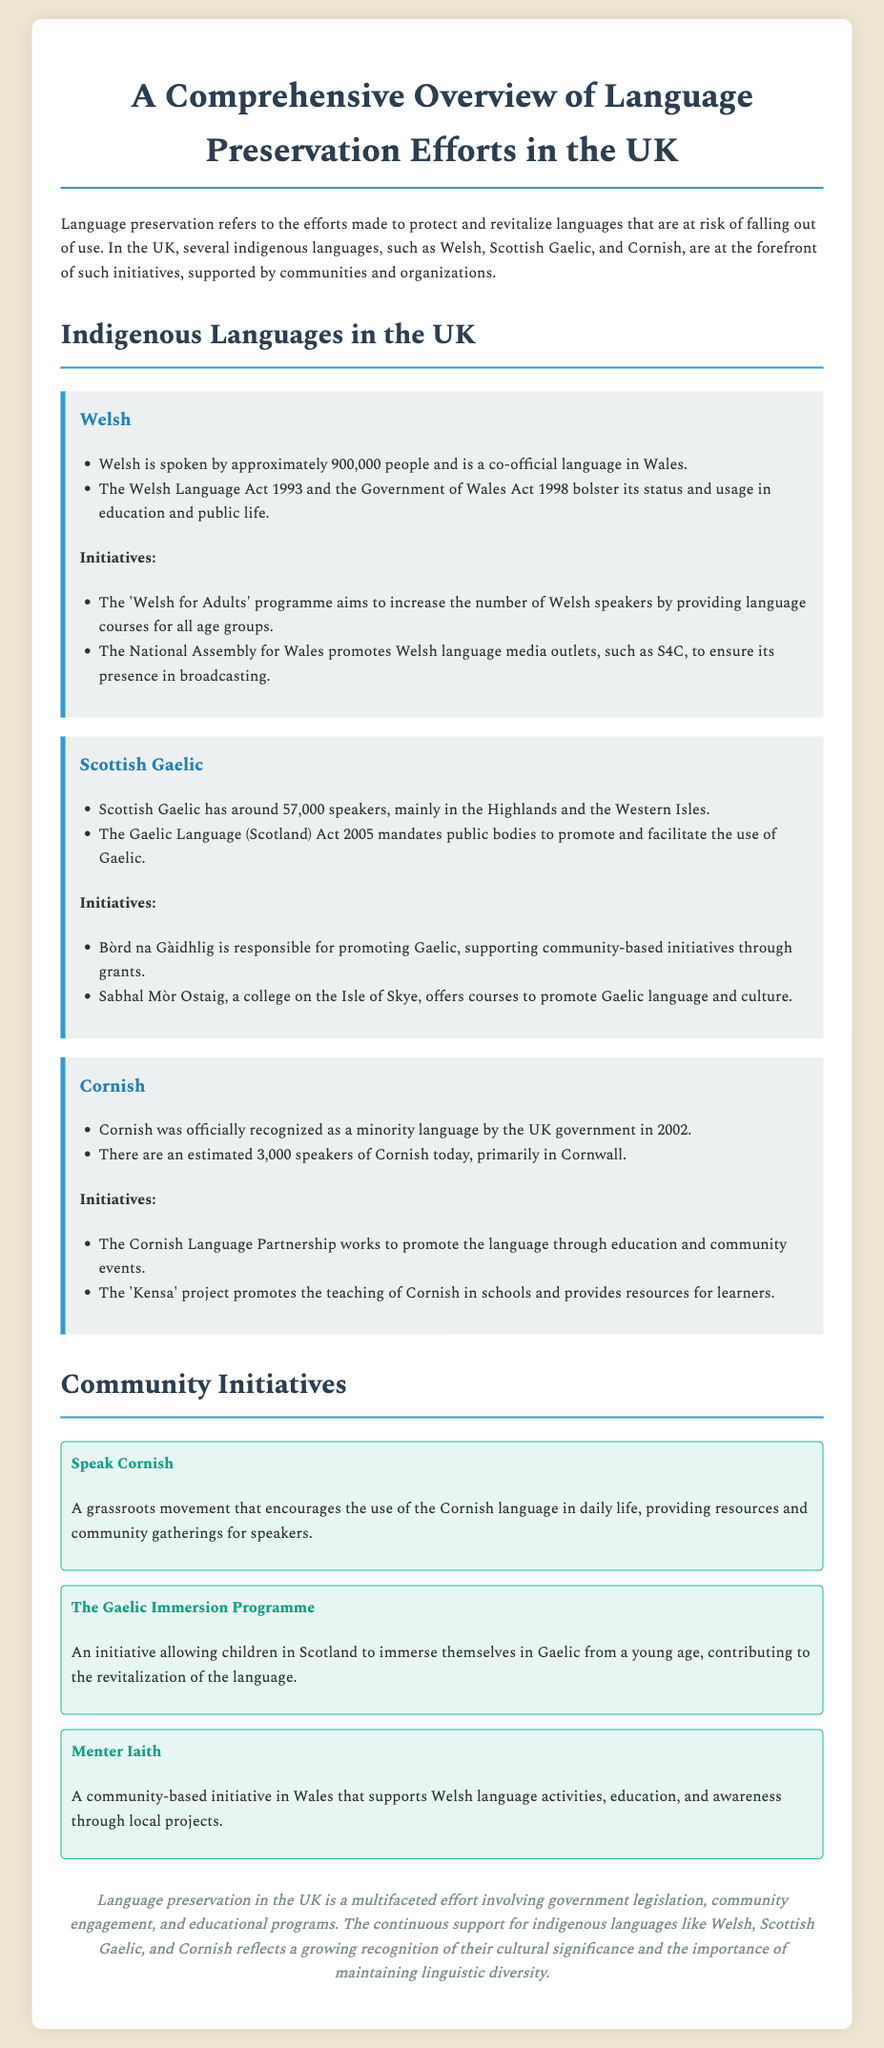What are the three indigenous languages mentioned? The document highlights Welsh, Scottish Gaelic, and Cornish as the indigenous languages being preserved in the UK.
Answer: Welsh, Scottish Gaelic, Cornish How many people speak Welsh? According to the document, Welsh is spoken by approximately 900,000 people.
Answer: 900,000 What act supports the Gaelic language in Scotland? The Gaelic Language (Scotland) Act 2005 mandates public bodies to support and promote Gaelic.
Answer: Gaelic Language (Scotland) Act 2005 What is the estimated number of Cornish speakers? The document states that there are approximately 3,000 speakers of Cornish today.
Answer: 3,000 What organization promotes Gaelic in Scotland? Bòrd na Gàidhlig is identified as the organization responsible for promoting Gaelic in Scotland.
Answer: Bòrd na Gàidhlig What is the purpose of the 'Speak Cornish' initiative? This grassroots movement encourages the use of the Cornish language in daily life, offering resources and gatherings.
Answer: Encourage use of Cornish in daily life How does the 'Welsh for Adults' programme contribute to language preservation? It aims to increase the number of Welsh speakers by providing language courses for all age groups.
Answer: Increase Welsh speakers What type of document is this? The document serves as a comprehensive overview detailing language preservation efforts in the UK, including case studies.
Answer: Comprehensive overview 